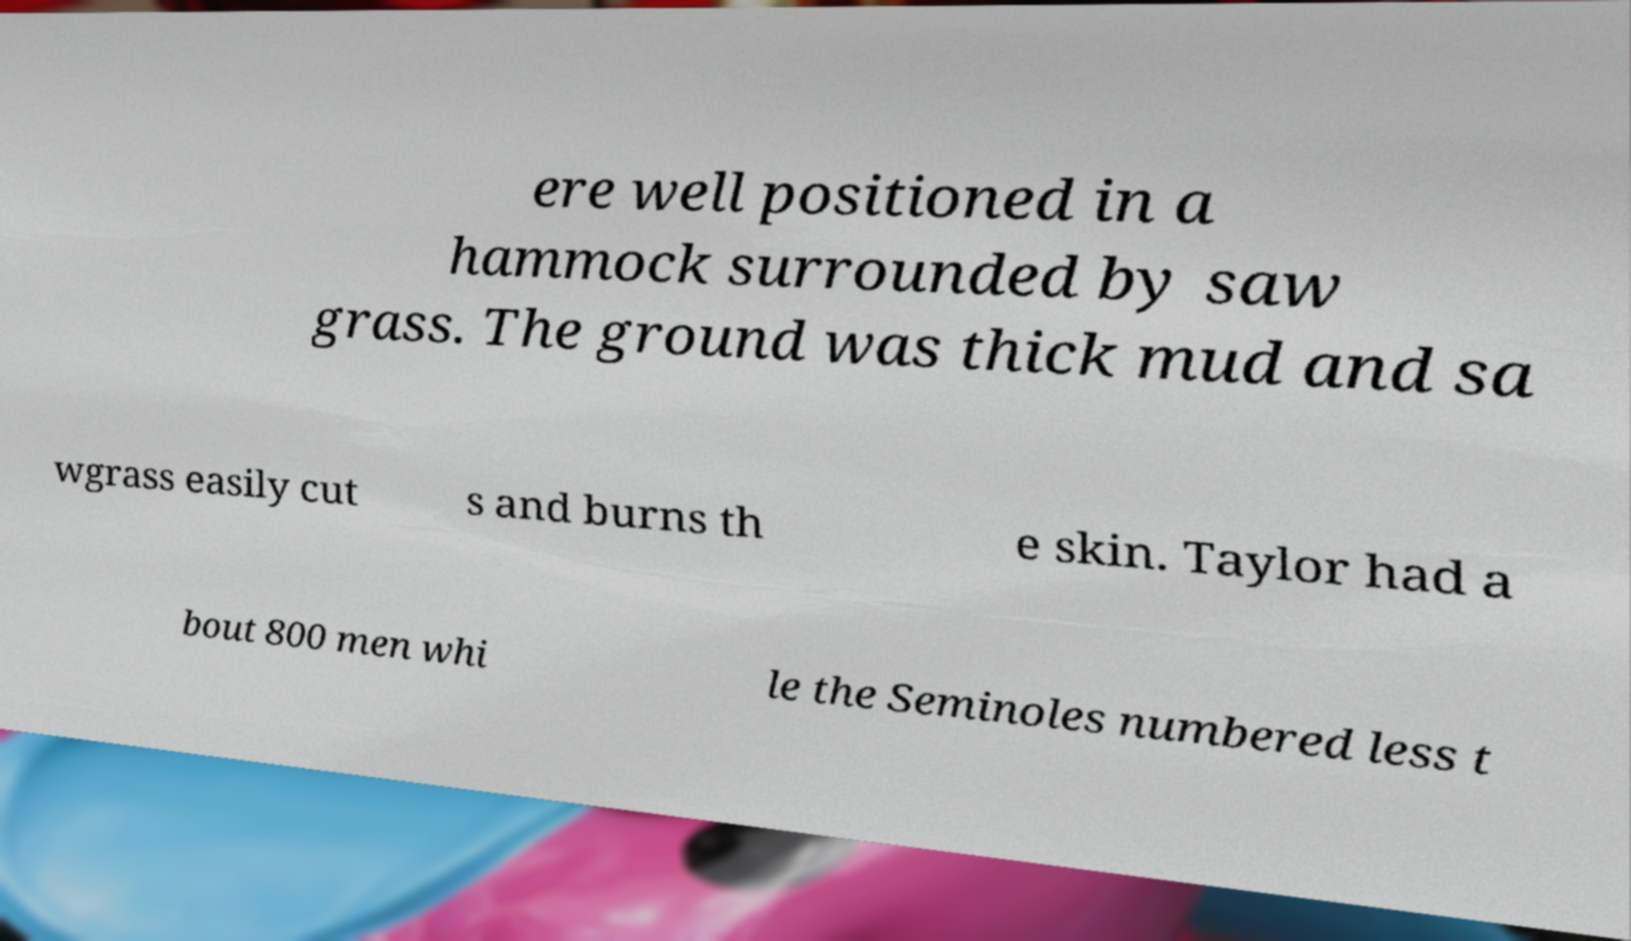Could you extract and type out the text from this image? ere well positioned in a hammock surrounded by saw grass. The ground was thick mud and sa wgrass easily cut s and burns th e skin. Taylor had a bout 800 men whi le the Seminoles numbered less t 